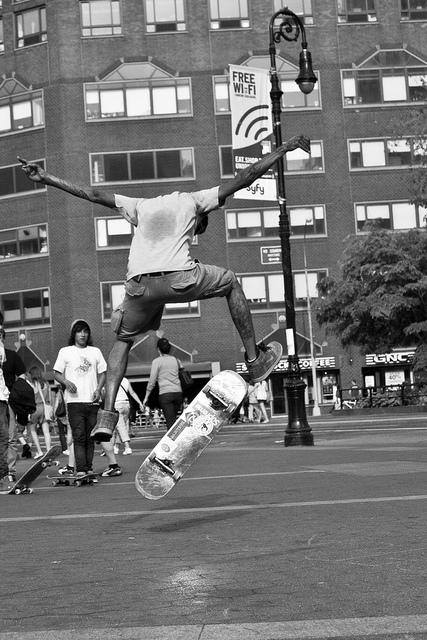What type of goods are sold in the store next to the tree? vitamins 